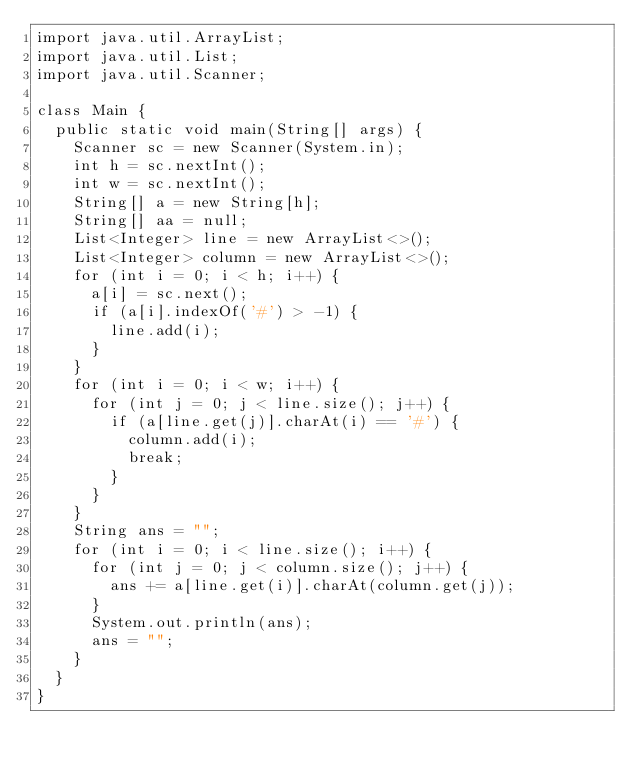<code> <loc_0><loc_0><loc_500><loc_500><_Java_>import java.util.ArrayList;
import java.util.List;
import java.util.Scanner;

class Main {
	public static void main(String[] args) {
		Scanner sc = new Scanner(System.in);
		int h = sc.nextInt();
		int w = sc.nextInt();
		String[] a = new String[h];
		String[] aa = null;
		List<Integer> line = new ArrayList<>();
		List<Integer> column = new ArrayList<>();
		for (int i = 0; i < h; i++) {
			a[i] = sc.next();
			if (a[i].indexOf('#') > -1) {
				line.add(i);
			}
		}
		for (int i = 0; i < w; i++) {
			for (int j = 0; j < line.size(); j++) {
				if (a[line.get(j)].charAt(i) == '#') {
					column.add(i);
					break;
				}
			}
		}
		String ans = "";
		for (int i = 0; i < line.size(); i++) {
			for (int j = 0; j < column.size(); j++) {
				ans += a[line.get(i)].charAt(column.get(j));
			}
			System.out.println(ans);
			ans = "";
		}
	}
}
</code> 